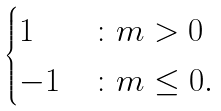Convert formula to latex. <formula><loc_0><loc_0><loc_500><loc_500>\begin{cases} 1 & \colon m > 0 \\ - 1 & \colon m \leq 0 . \end{cases}</formula> 